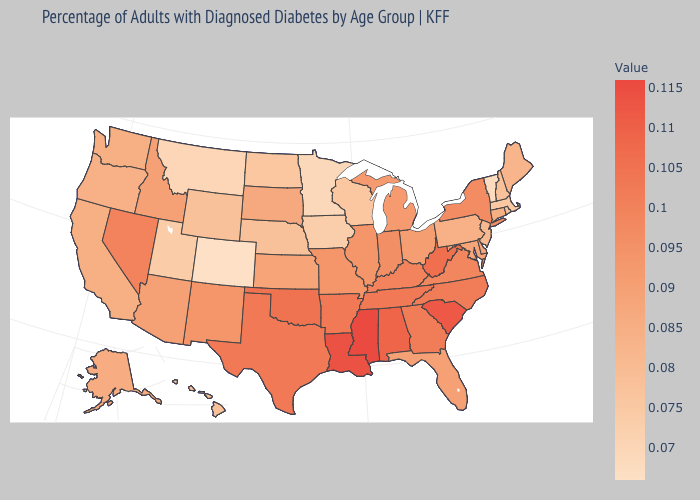Does Mississippi have a higher value than Kansas?
Write a very short answer. Yes. Does the map have missing data?
Give a very brief answer. No. Does the map have missing data?
Answer briefly. No. 